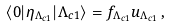Convert formula to latex. <formula><loc_0><loc_0><loc_500><loc_500>\langle 0 | \eta _ { \Lambda _ { c 1 } } | \Lambda _ { c 1 } \rangle = f _ { \Lambda _ { c 1 } } u _ { \Lambda _ { c 1 } } \, ,</formula> 